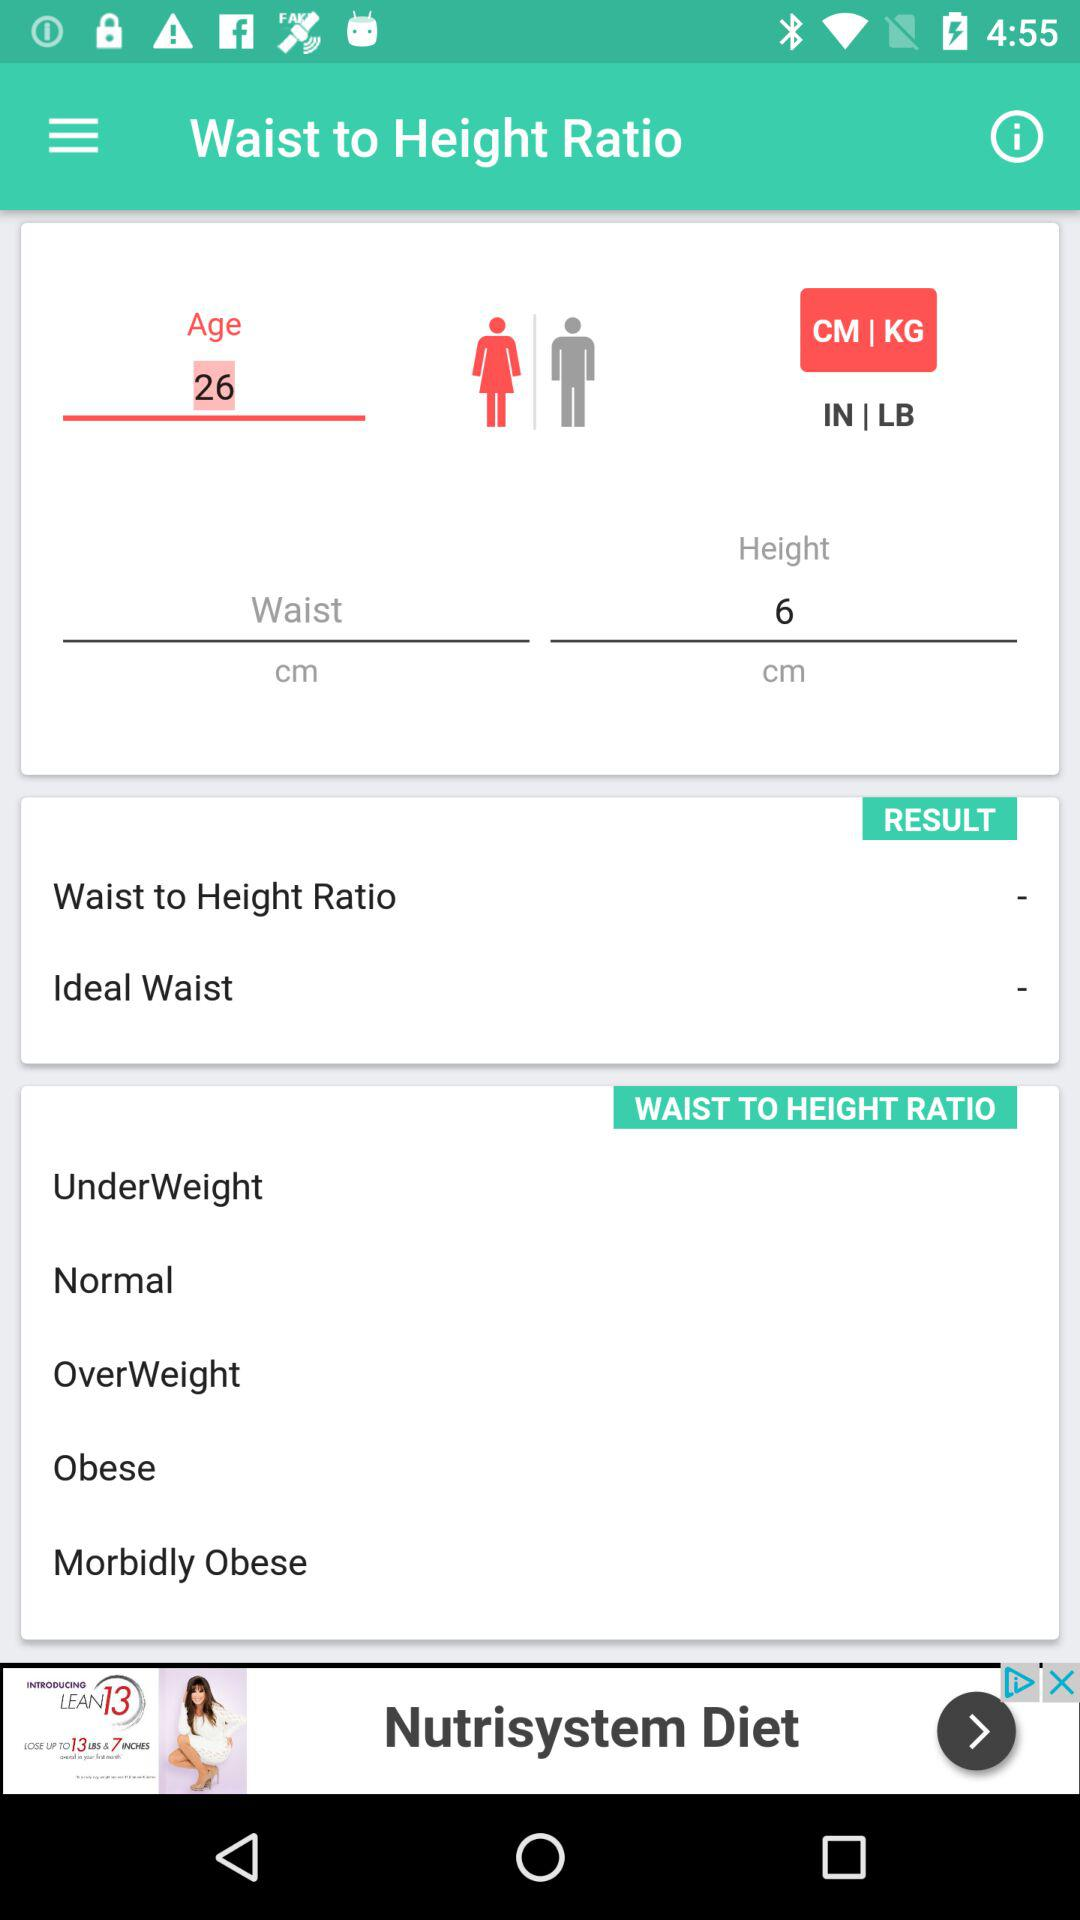What is the height? The height is 6 cm. 